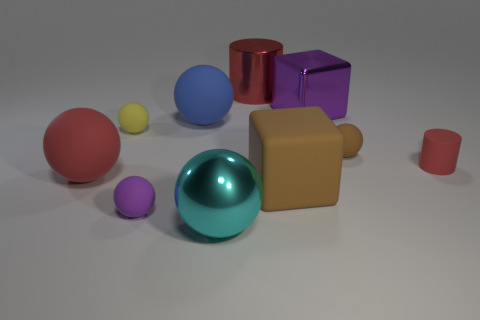Is there a big rubber object? Indeed, there appears to be a large rubber ball among the objects, characterized by its smooth texture and matte finish. 